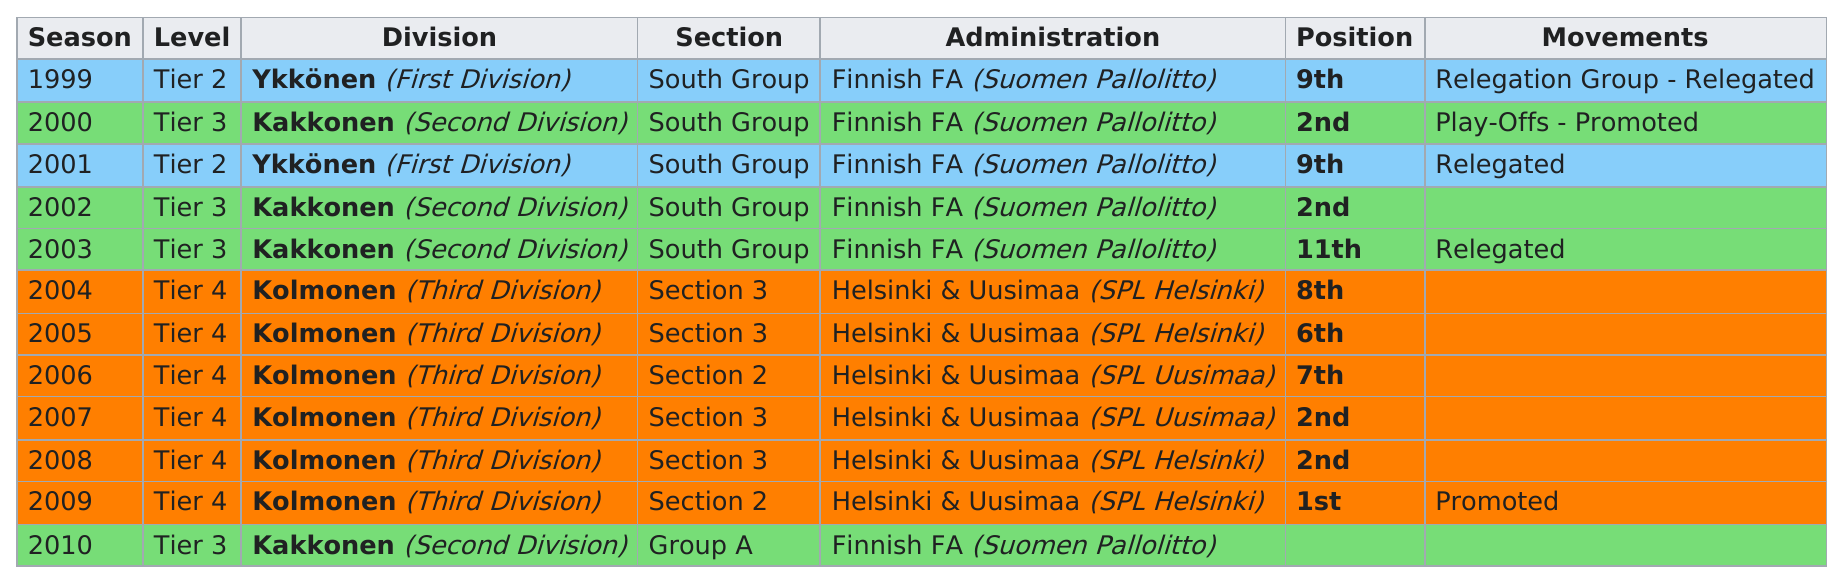List a handful of essential elements in this visual. The team that finished in 9th place in 1999 ultimately ended up in second place. Did any tier have multiple instances of being promoted and then immediately relegated? Four times were they in tier 3. There were a total of four 2nd positions. The Helsinki and Uusimaa administration has the least amount of division, as it is known as SPL Helsinki. 